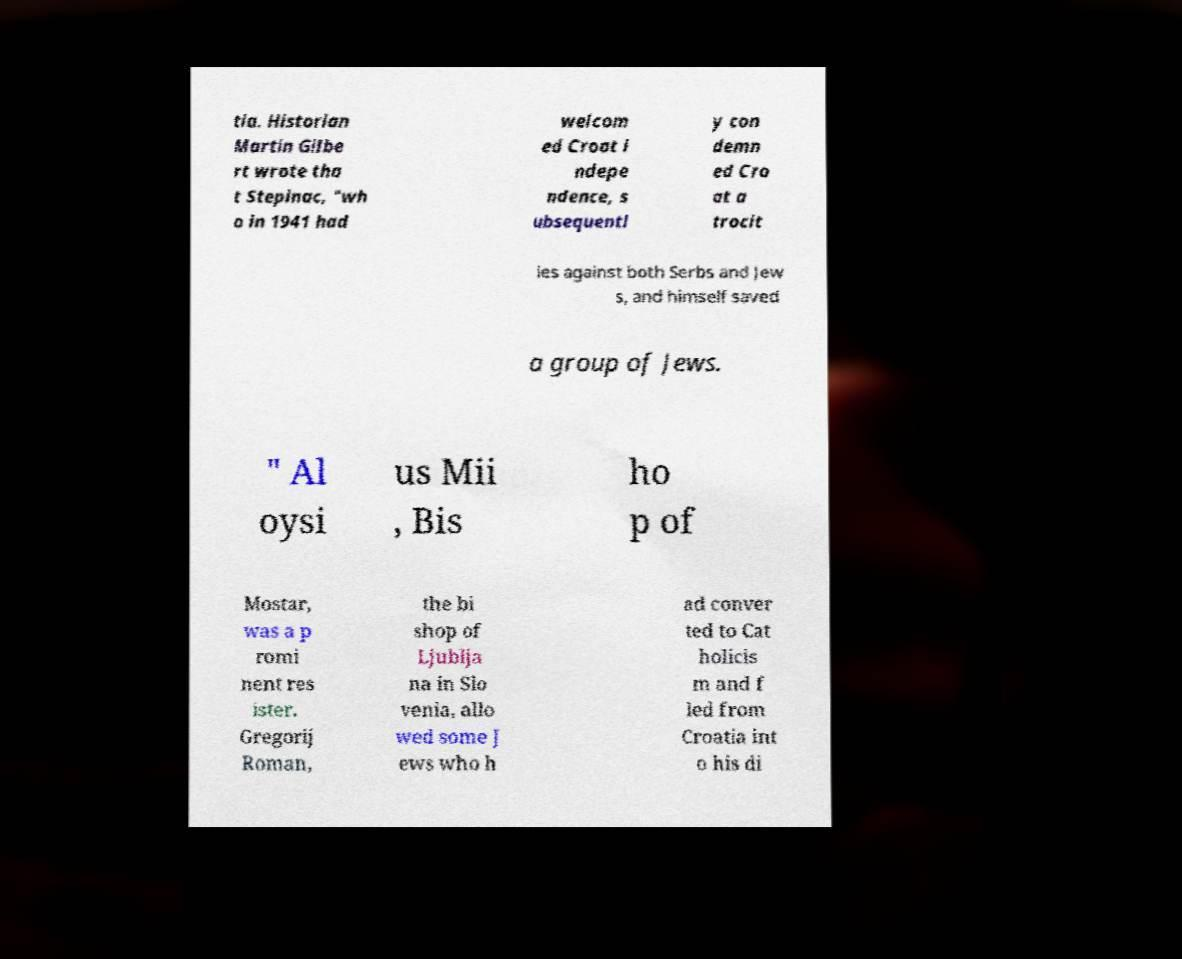Can you accurately transcribe the text from the provided image for me? tia. Historian Martin Gilbe rt wrote tha t Stepinac, "wh o in 1941 had welcom ed Croat i ndepe ndence, s ubsequentl y con demn ed Cro at a trocit ies against both Serbs and Jew s, and himself saved a group of Jews. " Al oysi us Mii , Bis ho p of Mostar, was a p romi nent res ister. Gregorij Roman, the bi shop of Ljublja na in Slo venia, allo wed some J ews who h ad conver ted to Cat holicis m and f led from Croatia int o his di 